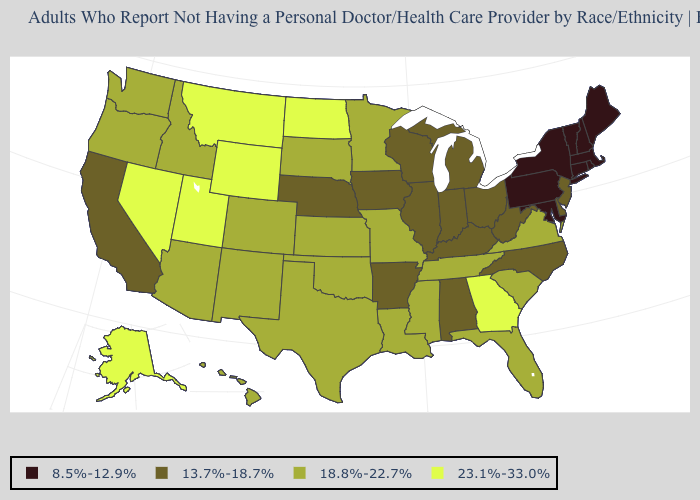What is the value of Massachusetts?
Keep it brief. 8.5%-12.9%. Does Illinois have the lowest value in the MidWest?
Be succinct. Yes. What is the value of Missouri?
Short answer required. 18.8%-22.7%. Does Maine have the same value as Maryland?
Quick response, please. Yes. What is the value of Mississippi?
Keep it brief. 18.8%-22.7%. Does North Dakota have the highest value in the USA?
Answer briefly. Yes. Which states have the lowest value in the MidWest?
Keep it brief. Illinois, Indiana, Iowa, Michigan, Nebraska, Ohio, Wisconsin. What is the value of Hawaii?
Write a very short answer. 18.8%-22.7%. What is the value of New Jersey?
Concise answer only. 13.7%-18.7%. Which states have the highest value in the USA?
Be succinct. Alaska, Georgia, Montana, Nevada, North Dakota, Utah, Wyoming. Name the states that have a value in the range 18.8%-22.7%?
Answer briefly. Arizona, Colorado, Florida, Hawaii, Idaho, Kansas, Louisiana, Minnesota, Mississippi, Missouri, New Mexico, Oklahoma, Oregon, South Carolina, South Dakota, Tennessee, Texas, Virginia, Washington. What is the highest value in states that border South Dakota?
Write a very short answer. 23.1%-33.0%. What is the value of Utah?
Be succinct. 23.1%-33.0%. How many symbols are there in the legend?
Quick response, please. 4. 